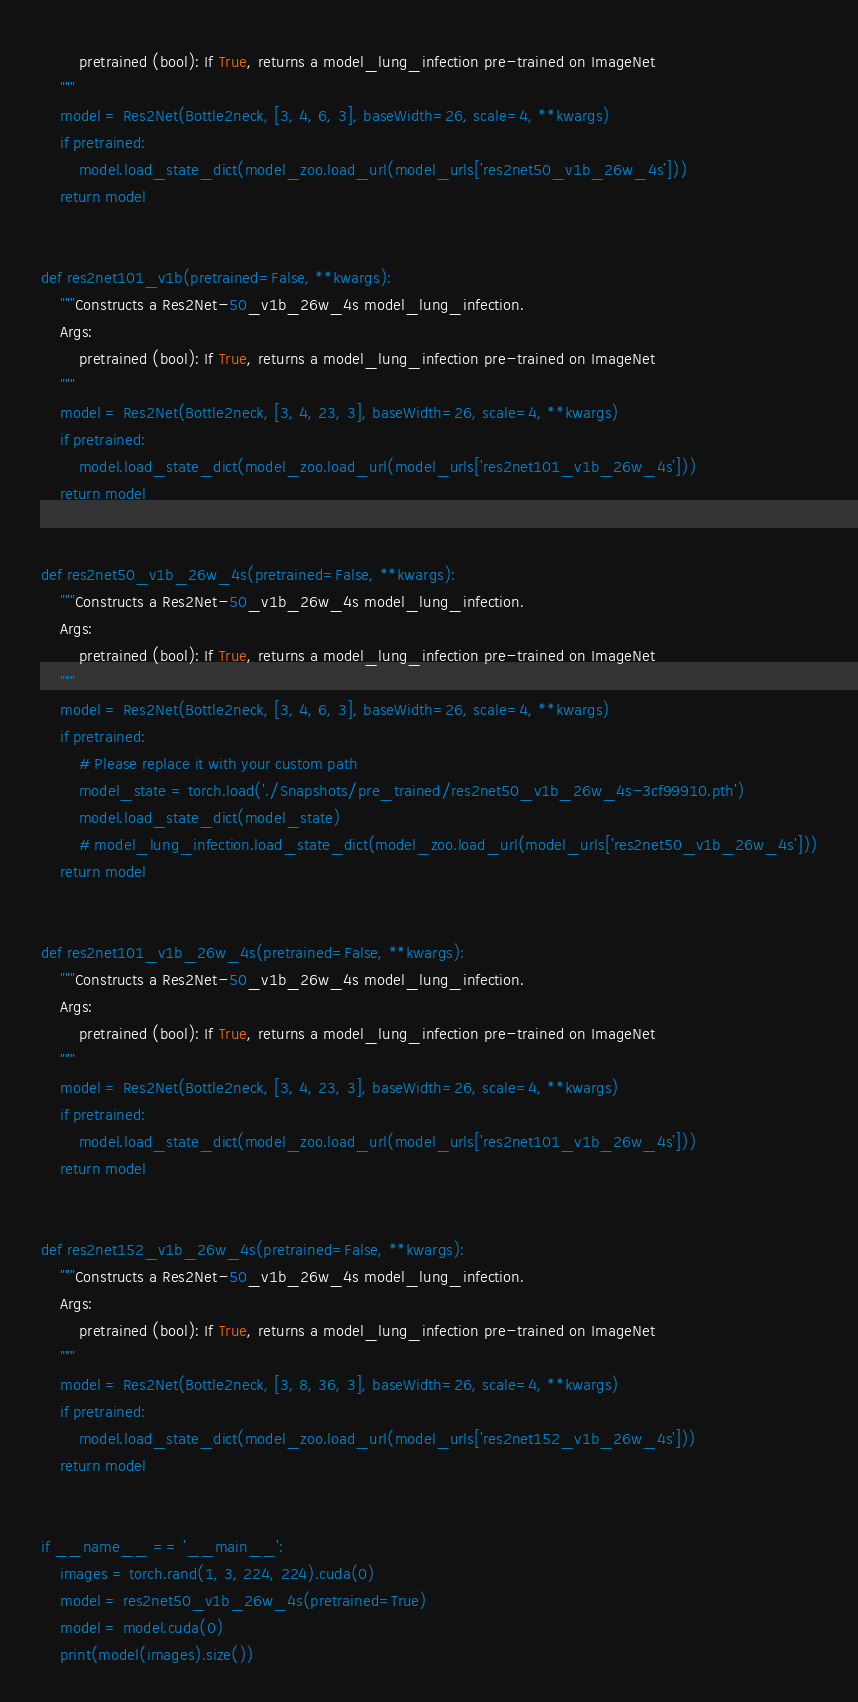Convert code to text. <code><loc_0><loc_0><loc_500><loc_500><_Python_>        pretrained (bool): If True, returns a model_lung_infection pre-trained on ImageNet
    """
    model = Res2Net(Bottle2neck, [3, 4, 6, 3], baseWidth=26, scale=4, **kwargs)
    if pretrained:
        model.load_state_dict(model_zoo.load_url(model_urls['res2net50_v1b_26w_4s']))
    return model


def res2net101_v1b(pretrained=False, **kwargs):
    """Constructs a Res2Net-50_v1b_26w_4s model_lung_infection.
    Args:
        pretrained (bool): If True, returns a model_lung_infection pre-trained on ImageNet
    """
    model = Res2Net(Bottle2neck, [3, 4, 23, 3], baseWidth=26, scale=4, **kwargs)
    if pretrained:
        model.load_state_dict(model_zoo.load_url(model_urls['res2net101_v1b_26w_4s']))
    return model


def res2net50_v1b_26w_4s(pretrained=False, **kwargs):
    """Constructs a Res2Net-50_v1b_26w_4s model_lung_infection.
    Args:
        pretrained (bool): If True, returns a model_lung_infection pre-trained on ImageNet
    """
    model = Res2Net(Bottle2neck, [3, 4, 6, 3], baseWidth=26, scale=4, **kwargs)
    if pretrained:
        # Please replace it with your custom path
        model_state = torch.load('./Snapshots/pre_trained/res2net50_v1b_26w_4s-3cf99910.pth')
        model.load_state_dict(model_state)
        # model_lung_infection.load_state_dict(model_zoo.load_url(model_urls['res2net50_v1b_26w_4s']))
    return model


def res2net101_v1b_26w_4s(pretrained=False, **kwargs):
    """Constructs a Res2Net-50_v1b_26w_4s model_lung_infection.
    Args:
        pretrained (bool): If True, returns a model_lung_infection pre-trained on ImageNet
    """
    model = Res2Net(Bottle2neck, [3, 4, 23, 3], baseWidth=26, scale=4, **kwargs)
    if pretrained:
        model.load_state_dict(model_zoo.load_url(model_urls['res2net101_v1b_26w_4s']))
    return model


def res2net152_v1b_26w_4s(pretrained=False, **kwargs):
    """Constructs a Res2Net-50_v1b_26w_4s model_lung_infection.
    Args:
        pretrained (bool): If True, returns a model_lung_infection pre-trained on ImageNet
    """
    model = Res2Net(Bottle2neck, [3, 8, 36, 3], baseWidth=26, scale=4, **kwargs)
    if pretrained:
        model.load_state_dict(model_zoo.load_url(model_urls['res2net152_v1b_26w_4s']))
    return model


if __name__ == '__main__':
    images = torch.rand(1, 3, 224, 224).cuda(0)
    model = res2net50_v1b_26w_4s(pretrained=True)
    model = model.cuda(0)
    print(model(images).size())</code> 